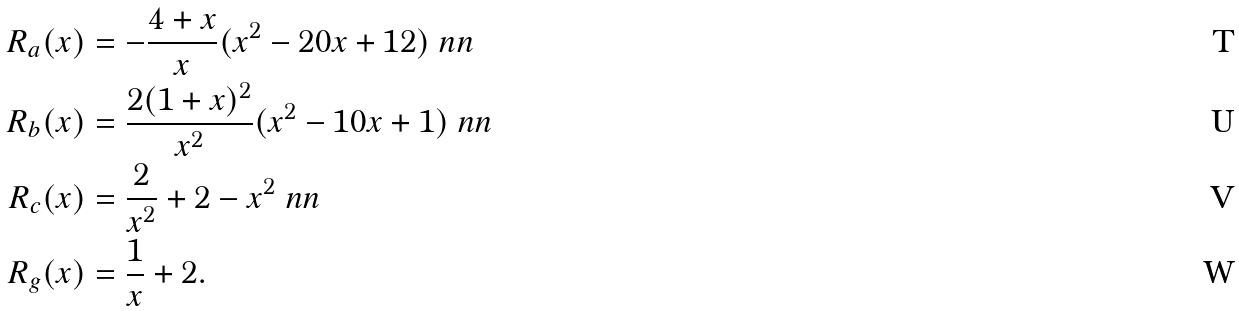Convert formula to latex. <formula><loc_0><loc_0><loc_500><loc_500>R _ { a } ( x ) & = - \frac { 4 + x } { x } ( x ^ { 2 } - 2 0 x + 1 2 ) \ n n \\ R _ { b } ( x ) & = \frac { 2 ( 1 + x ) ^ { 2 } } { x ^ { 2 } } ( x ^ { 2 } - 1 0 x + 1 ) \ n n \\ R _ { c } ( x ) & = \frac { 2 } { x ^ { 2 } } + 2 - x ^ { 2 } \ n n \\ R _ { g } ( x ) & = \frac { 1 } { x } + 2 .</formula> 